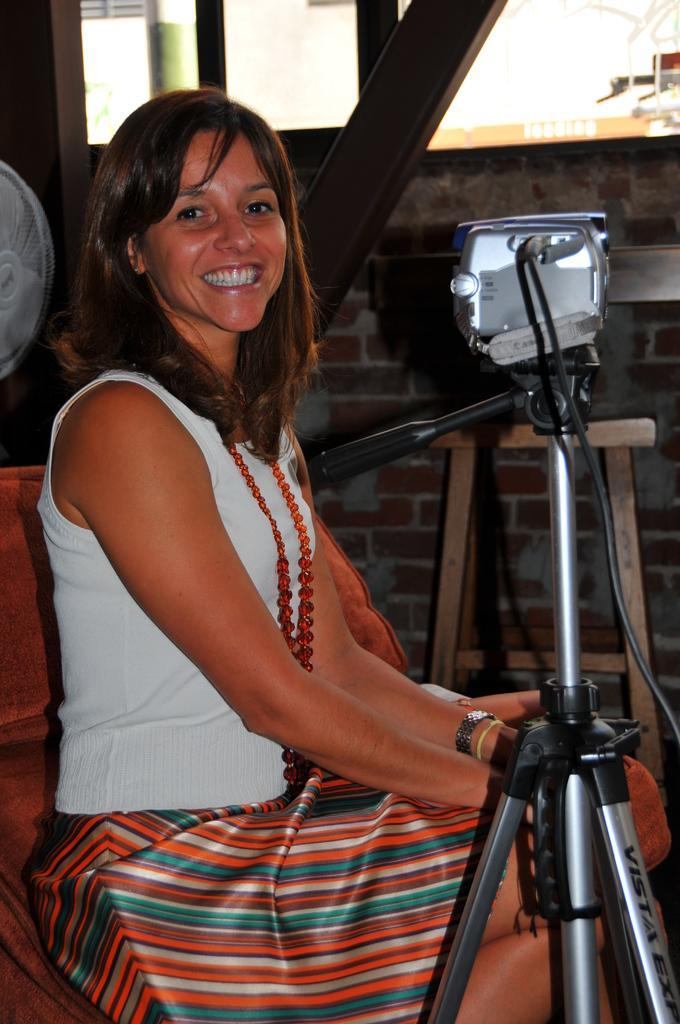What is the woman in the image doing? The woman is sitting on a chair in the image. What is the woman's facial expression in the image? The woman is smiling in the image. What can be seen on the left side of the image? There is a stand in the image. What is the woman holding in the image? The woman is holding a camera in the image. What can be seen in the background of the image? There is a fan, a stool, and a wall in the background of the image. What type of bun is the woman wearing in the image? There is no bun visible on the woman's head in the image. What achievement is the woman being recognized for in the image? There is no indication in the image that the woman is being recognized for any achievement. 